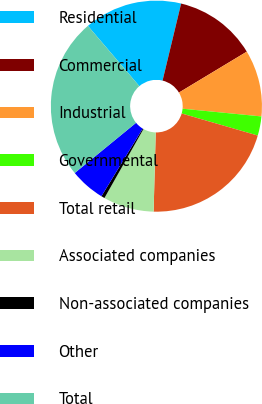Convert chart. <chart><loc_0><loc_0><loc_500><loc_500><pie_chart><fcel>Residential<fcel>Commercial<fcel>Industrial<fcel>Governmental<fcel>Total retail<fcel>Associated companies<fcel>Non-associated companies<fcel>Other<fcel>Total<nl><fcel>15.01%<fcel>12.6%<fcel>10.19%<fcel>2.94%<fcel>20.93%<fcel>7.77%<fcel>0.53%<fcel>5.36%<fcel>24.67%<nl></chart> 